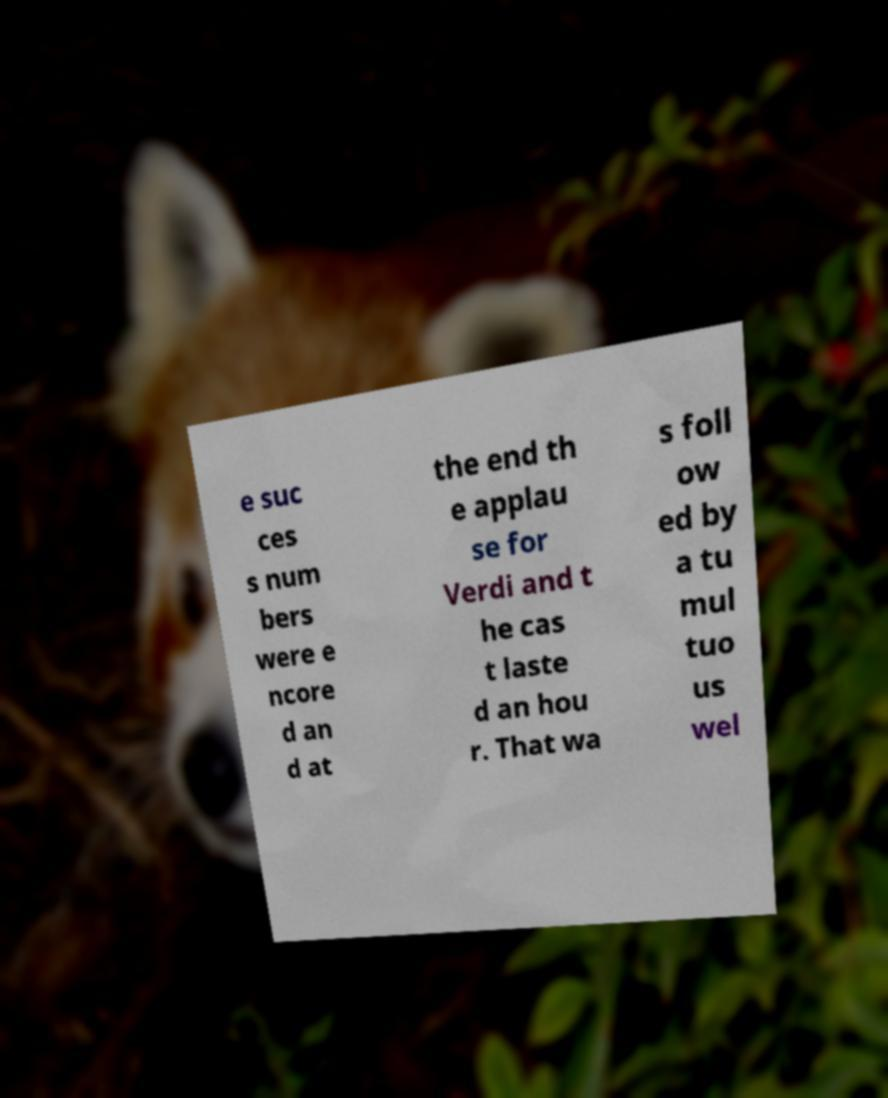For documentation purposes, I need the text within this image transcribed. Could you provide that? e suc ces s num bers were e ncore d an d at the end th e applau se for Verdi and t he cas t laste d an hou r. That wa s foll ow ed by a tu mul tuo us wel 